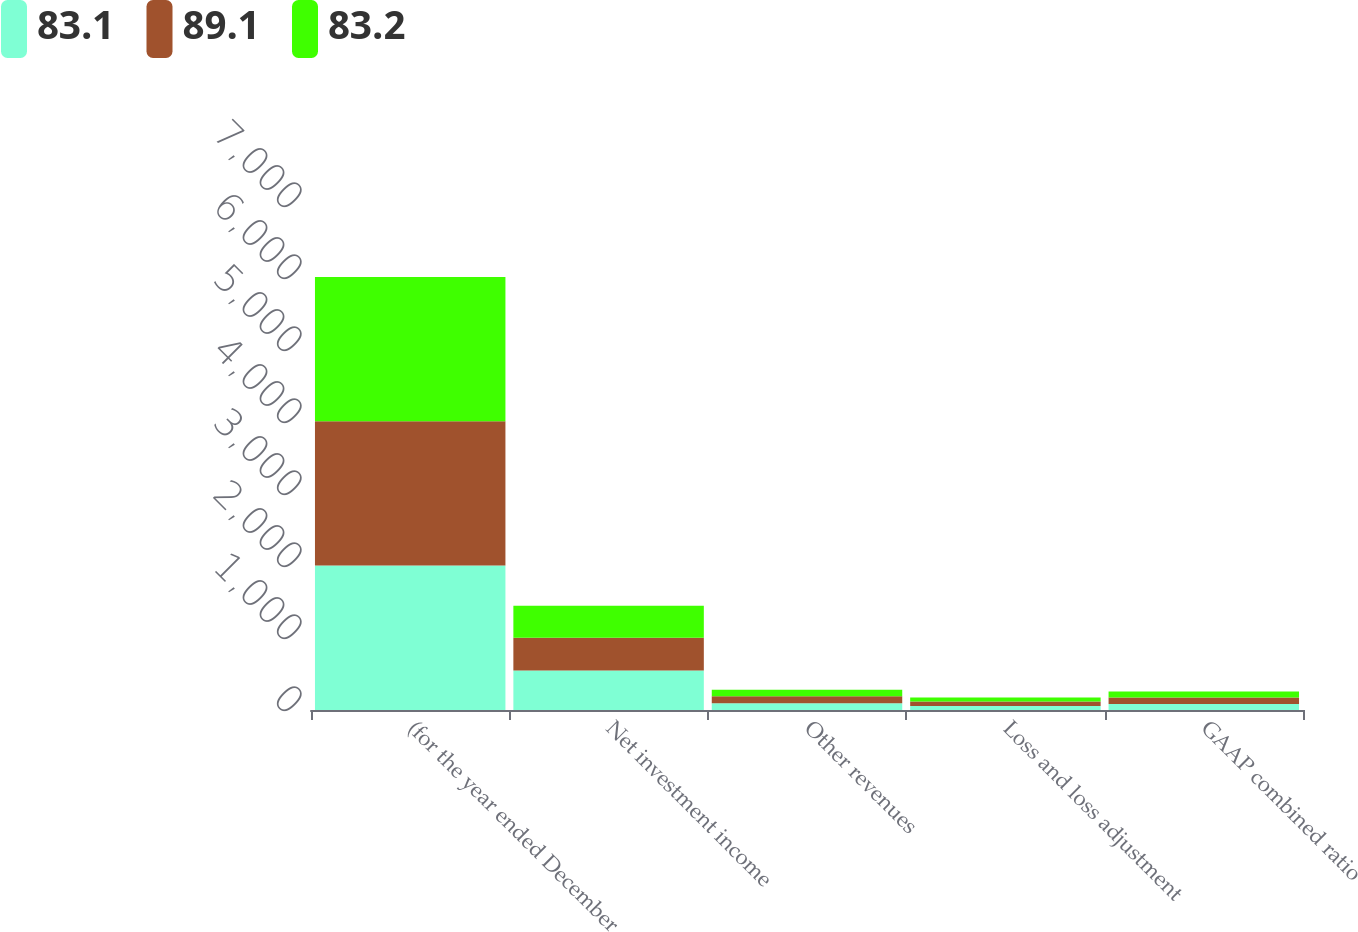Convert chart. <chart><loc_0><loc_0><loc_500><loc_500><stacked_bar_chart><ecel><fcel>(for the year ended December<fcel>Net investment income<fcel>Other revenues<fcel>Loss and loss adjustment<fcel>GAAP combined ratio<nl><fcel>83.1<fcel>2006<fcel>548<fcel>94<fcel>54.8<fcel>83.1<nl><fcel>89.1<fcel>2005<fcel>457<fcel>96<fcel>62.2<fcel>89.1<nl><fcel>83.2<fcel>2004<fcel>442<fcel>91<fcel>58.3<fcel>83.2<nl></chart> 